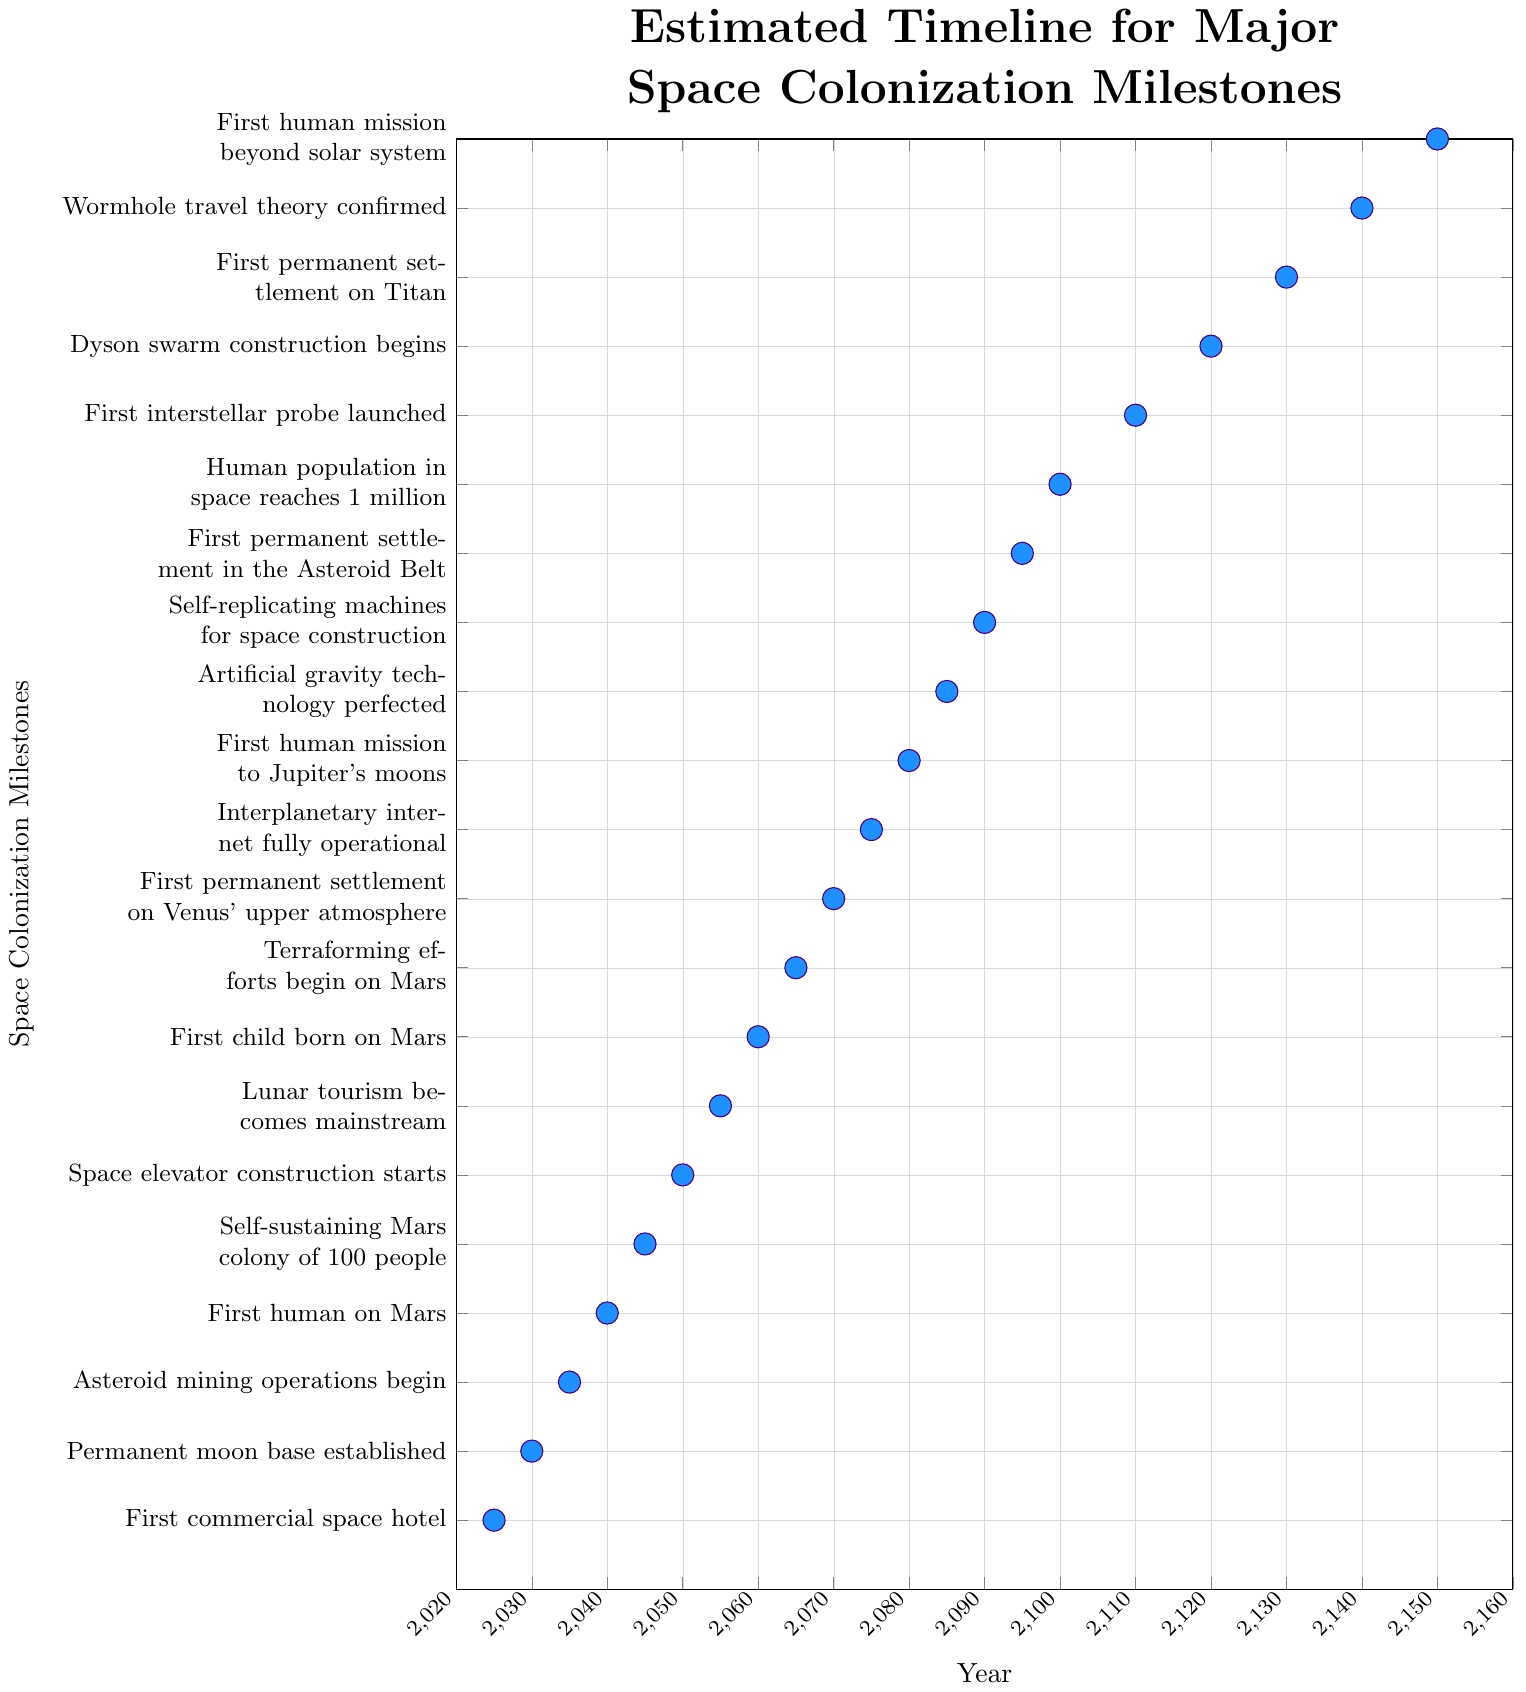What's the first major milestone in space colonization according to the timeline? The dot at the bottom of the Y-axis corresponds to the first milestone labeled as "First commercial space hotel" with the year 2025 on the X-axis.
Answer: First commercial space hotel in 2025 What is the last milestone and when will it occur? The topmost dot on the Y-axis represents the final milestone labeled as "First human mission beyond solar system", which occurs in the year 2150 on the X-axis.
Answer: First human mission beyond solar system in 2150 Which milestone is projected to occur around 2040? Locate the dot on the X-axis at 2040, and follow it to the corresponding Y-axis label which is "First human on Mars".
Answer: First human on Mars How many milestones are expected to occur before 2100? Count the number of dots on the X-axis before the year 2100: 15 milestones from 2025 to 2095.
Answer: 15 milestones What is the difference in years between the first human mission to Mars and the establishment of a self-sustaining Mars colony of 100 people? The first human mission to Mars is in 2040 and the self-sustaining Mars colony is in 2045, giving a difference of 5 years.
Answer: 5 years What milestone is achieved at the midway point between 2025 and 2150? The midway year between 2025 and 2150 is (2025 + 2150) / 2 = 2087.5, approximating to 2085. The milestone at 2085 corresponds to "Artificial gravity technology perfected".
Answer: Artificial gravity technology perfected Which milestone occurs directly after the permanent moon base is established? After "Permanent moon base established" in 2030, the next milestone at 2035 is "Asteroid mining operations begin".
Answer: Asteroid mining operations begin Which milestone expected in 2070 represents a significant breakthrough in planetary colonization? Locate the dot in 2070, corresponding to "First permanent settlement on Venus' upper atmosphere".
Answer: First permanent settlement on Venus' upper atmosphere Compare the years for milestones involving Mars, and state which occurs first and last. Review the milestones related to Mars:
- First human on Mars (2040)
- Self-sustaining Mars colony (2045)
- First child born on Mars (2060)
- Terraforming efforts begin on Mars (2065)
The earliest is "First human on Mars" and the latest is "Terraforming efforts begin on Mars".
Answer: First human on Mars in 2040, Terraforming efforts begin on Mars in 2065 What significant technological development is projected for 2130, and how does it relate to the timeline? Locate the milestone for the year 2130: "First permanent settlement on Titan". It illustrates the expansion of human presence to Saturn's moon Titan within the context of space colonization milestones.
Answer: First permanent settlement on Titan 